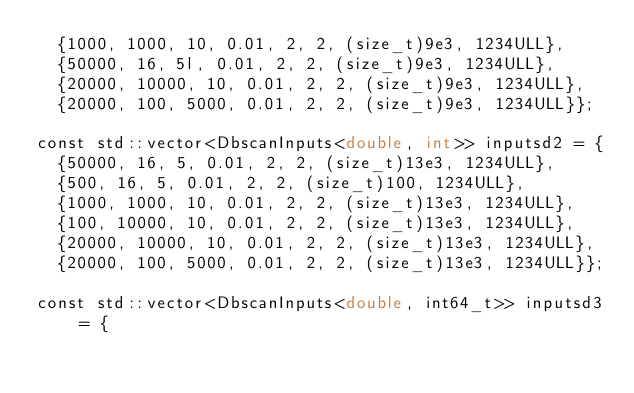<code> <loc_0><loc_0><loc_500><loc_500><_Cuda_>  {1000, 1000, 10, 0.01, 2, 2, (size_t)9e3, 1234ULL},
  {50000, 16, 5l, 0.01, 2, 2, (size_t)9e3, 1234ULL},
  {20000, 10000, 10, 0.01, 2, 2, (size_t)9e3, 1234ULL},
  {20000, 100, 5000, 0.01, 2, 2, (size_t)9e3, 1234ULL}};

const std::vector<DbscanInputs<double, int>> inputsd2 = {
  {50000, 16, 5, 0.01, 2, 2, (size_t)13e3, 1234ULL},
  {500, 16, 5, 0.01, 2, 2, (size_t)100, 1234ULL},
  {1000, 1000, 10, 0.01, 2, 2, (size_t)13e3, 1234ULL},
  {100, 10000, 10, 0.01, 2, 2, (size_t)13e3, 1234ULL},
  {20000, 10000, 10, 0.01, 2, 2, (size_t)13e3, 1234ULL},
  {20000, 100, 5000, 0.01, 2, 2, (size_t)13e3, 1234ULL}};

const std::vector<DbscanInputs<double, int64_t>> inputsd3 = {</code> 